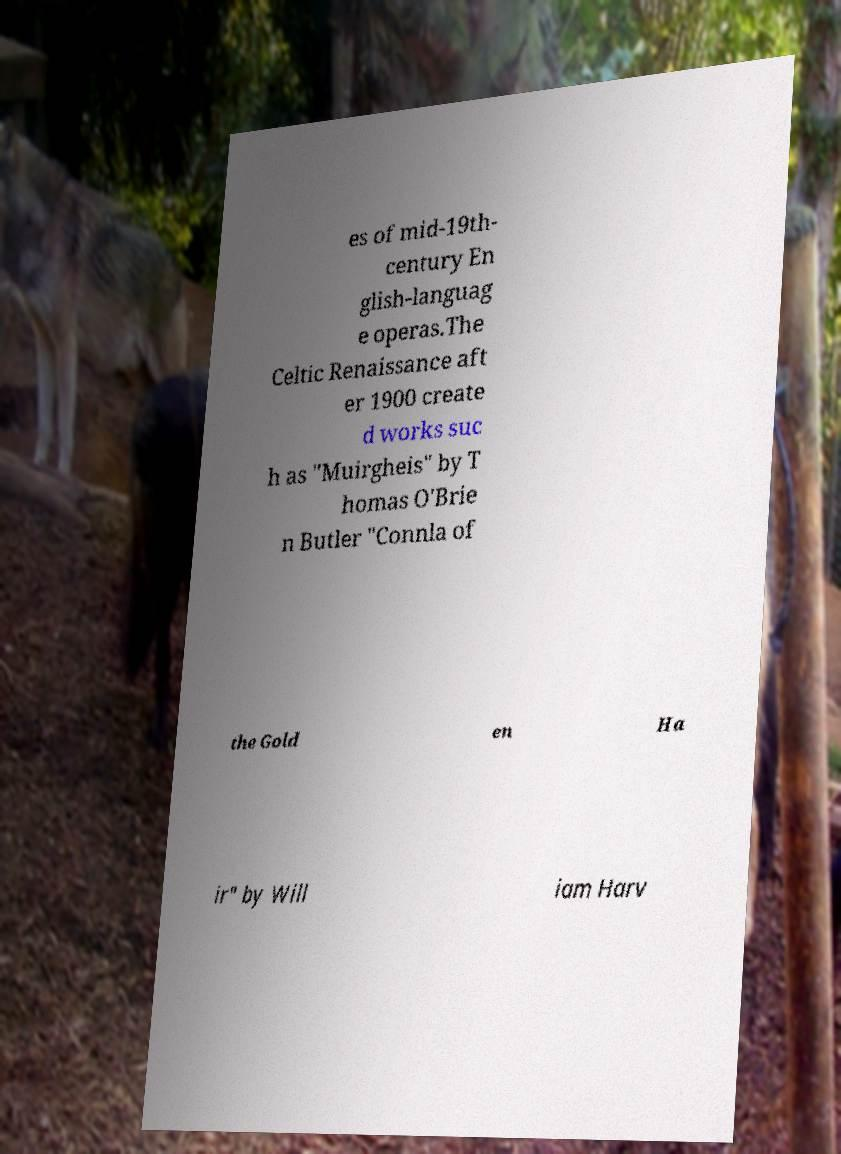For documentation purposes, I need the text within this image transcribed. Could you provide that? es of mid-19th- century En glish-languag e operas.The Celtic Renaissance aft er 1900 create d works suc h as "Muirgheis" by T homas O'Brie n Butler "Connla of the Gold en Ha ir" by Will iam Harv 